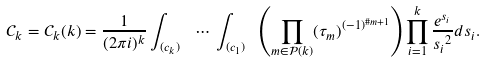Convert formula to latex. <formula><loc_0><loc_0><loc_500><loc_500>\mathcal { C } _ { k } = \mathcal { C } _ { k } ( k ) = \frac { 1 } { ( 2 \pi i ) ^ { k } } \int _ { ( c _ { k } ) \ } \, \cdots \, \int _ { ( c _ { 1 } ) \ } \left ( \prod _ { m \in \mathcal { P } ( k ) } ( \tau _ { m } ) ^ { ( - 1 ) ^ { \# m + 1 } } \right ) \prod _ { i = 1 } ^ { k } \frac { e ^ { s _ { i } } } { { s _ { i } } ^ { 2 } } d s _ { i } .</formula> 